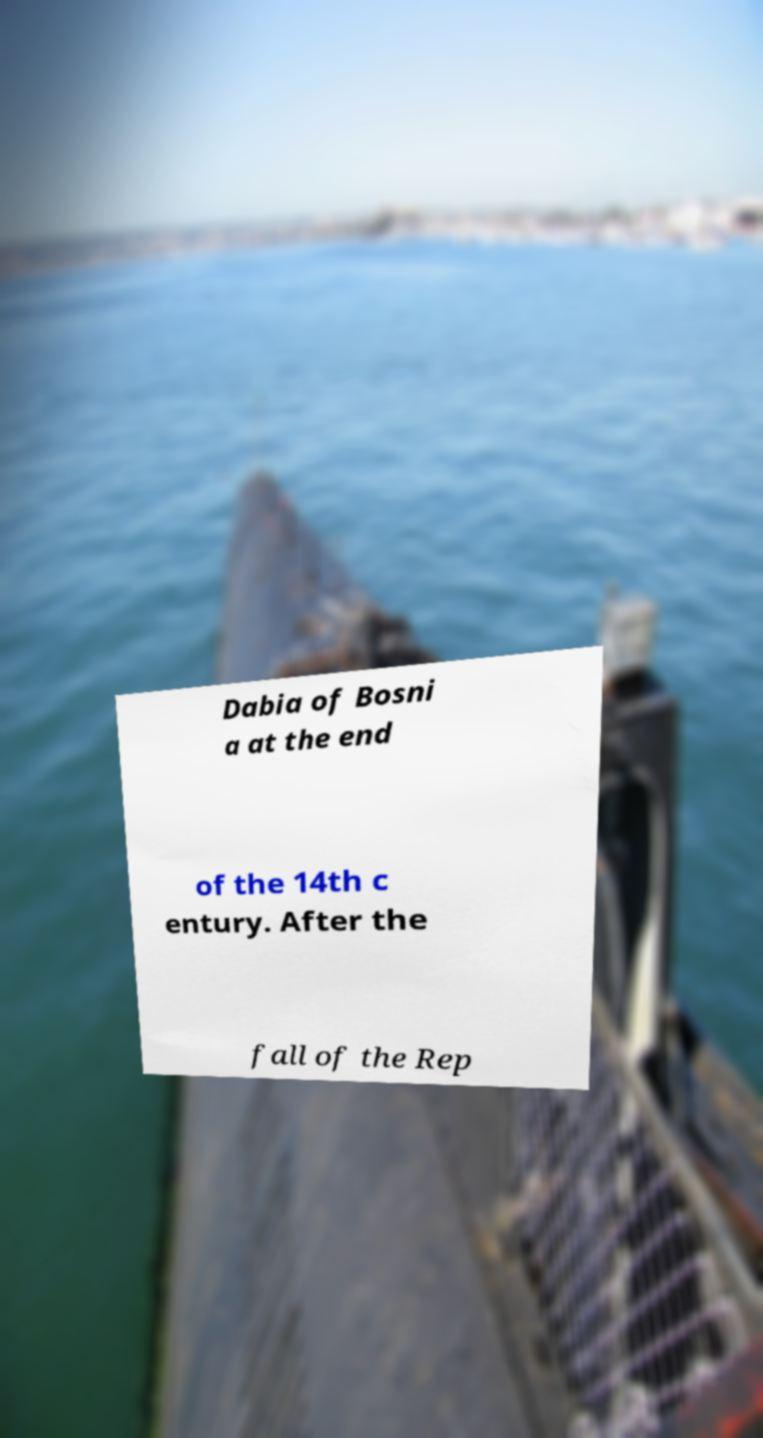Can you read and provide the text displayed in the image?This photo seems to have some interesting text. Can you extract and type it out for me? Dabia of Bosni a at the end of the 14th c entury. After the fall of the Rep 